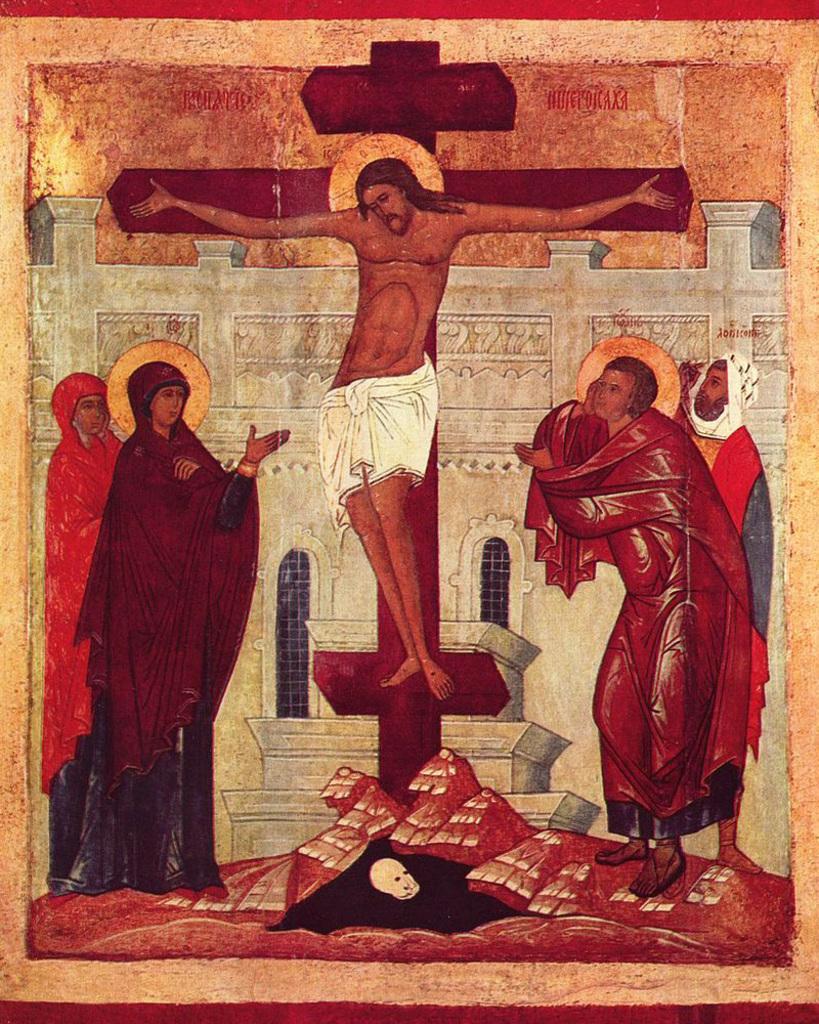In one or two sentences, can you explain what this image depicts? In this image we can see a drawing of people. There is a building with windows. There is a cross sign. 